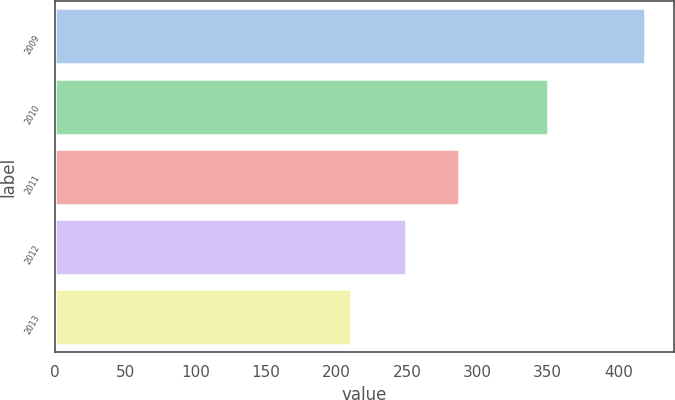Convert chart. <chart><loc_0><loc_0><loc_500><loc_500><bar_chart><fcel>2009<fcel>2010<fcel>2011<fcel>2012<fcel>2013<nl><fcel>419<fcel>350<fcel>287<fcel>249<fcel>210<nl></chart> 